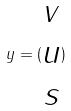Convert formula to latex. <formula><loc_0><loc_0><loc_500><loc_500>y = ( \begin{matrix} v \\ u \\ s \end{matrix} )</formula> 